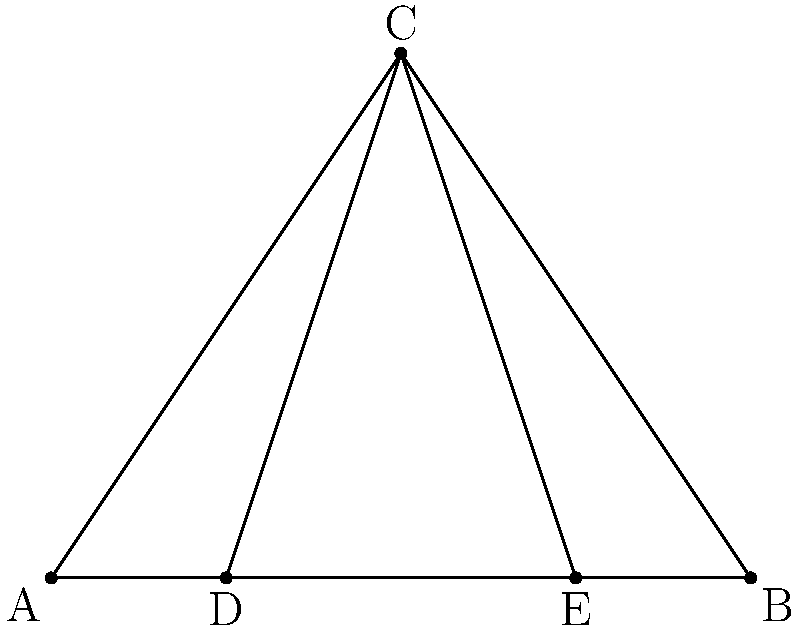In the diagram above, which represents a simplified Gothic arch, triangle ABC forms the overall shape of the arch. Points D and E are located on the base AB such that AD:DB = 1:3 and BE:EA = 1:3. If the height of the arch (BC) is 3 units and the width (AB) is 4 units, what is the ratio of the angles ∠ACD : ∠BCE? To solve this problem, we'll follow these steps:

1) First, we need to calculate the angles ∠ACD and ∠BCE.

2) In right triangle ACD:
   - Base AD = 1 unit (since AD:DB = 1:3 and AB = 4 units)
   - Height CD = 3 units (given)
   - tan(∠ACD) = CD/AD = 3/1 = 3
   - ∠ACD = arctan(3) ≈ 71.57°

3) In right triangle BCE:
   - Base BE = 1 unit (since BE:EA = 1:3 and AB = 4 units)
   - Height CE = 3 units (given)
   - tan(∠BCE) = CE/BE = 3/1 = 3
   - ∠BCE = arctan(3) ≈ 71.57°

4) We can see that ∠ACD = ∠BCE

5) Therefore, the ratio ∠ACD : ∠BCE = 1 : 1

This result demonstrates the symmetry often found in Gothic arches, where the angles on either side of the central vertical axis are equal. This symmetry contributes to the structural stability and aesthetic appeal of Gothic architecture.
Answer: 1:1 